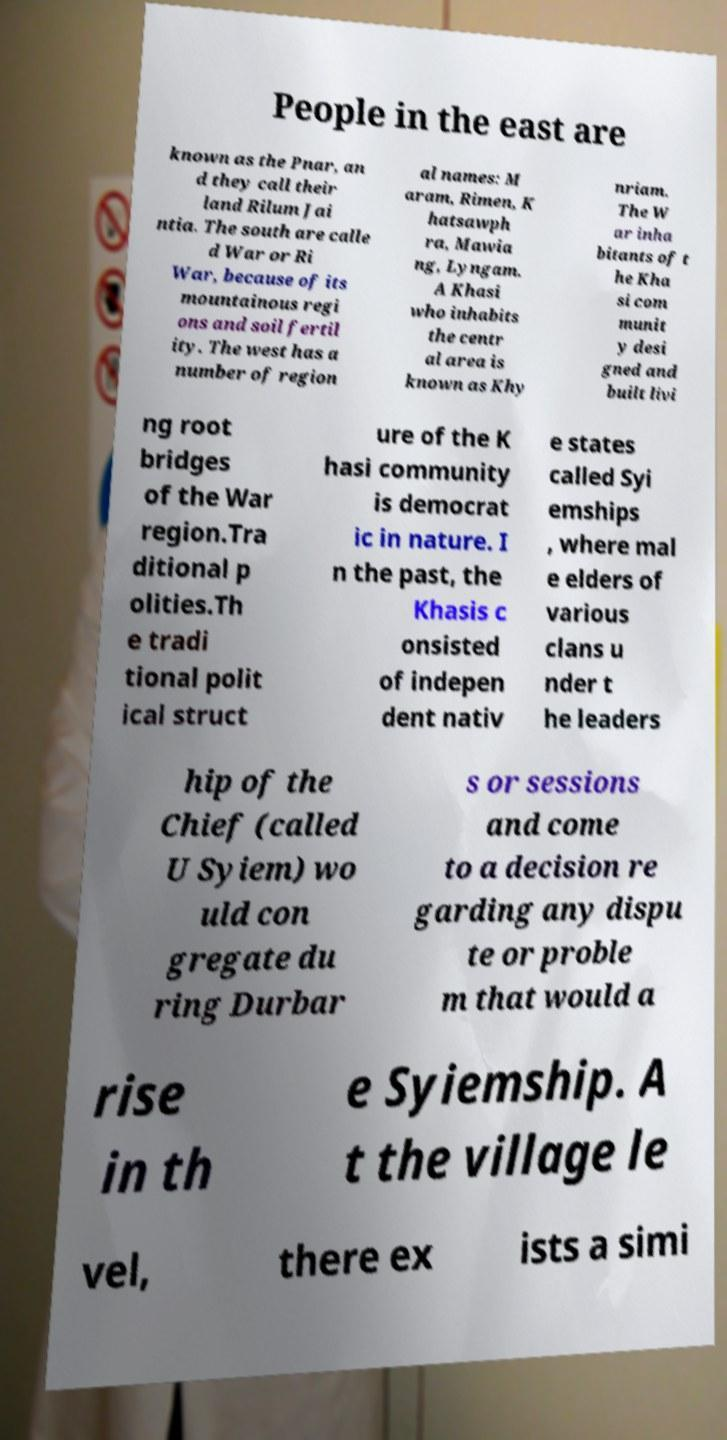There's text embedded in this image that I need extracted. Can you transcribe it verbatim? People in the east are known as the Pnar, an d they call their land Rilum Jai ntia. The south are calle d War or Ri War, because of its mountainous regi ons and soil fertil ity. The west has a number of region al names: M aram, Rimen, K hatsawph ra, Mawia ng, Lyngam. A Khasi who inhabits the centr al area is known as Khy nriam. The W ar inha bitants of t he Kha si com munit y desi gned and built livi ng root bridges of the War region.Tra ditional p olities.Th e tradi tional polit ical struct ure of the K hasi community is democrat ic in nature. I n the past, the Khasis c onsisted of indepen dent nativ e states called Syi emships , where mal e elders of various clans u nder t he leaders hip of the Chief (called U Syiem) wo uld con gregate du ring Durbar s or sessions and come to a decision re garding any dispu te or proble m that would a rise in th e Syiemship. A t the village le vel, there ex ists a simi 